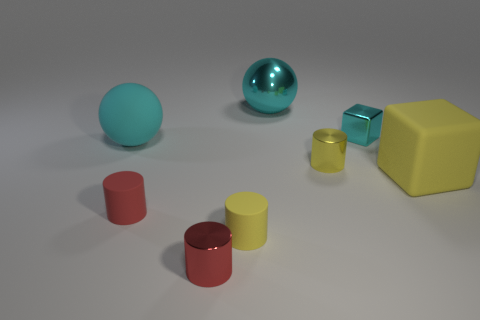Subtract 1 cylinders. How many cylinders are left? 3 Add 1 tiny brown matte spheres. How many objects exist? 9 Subtract all balls. How many objects are left? 6 Add 4 cubes. How many cubes are left? 6 Add 8 large cyan spheres. How many large cyan spheres exist? 10 Subtract 0 purple balls. How many objects are left? 8 Subtract all yellow matte things. Subtract all yellow metallic cylinders. How many objects are left? 5 